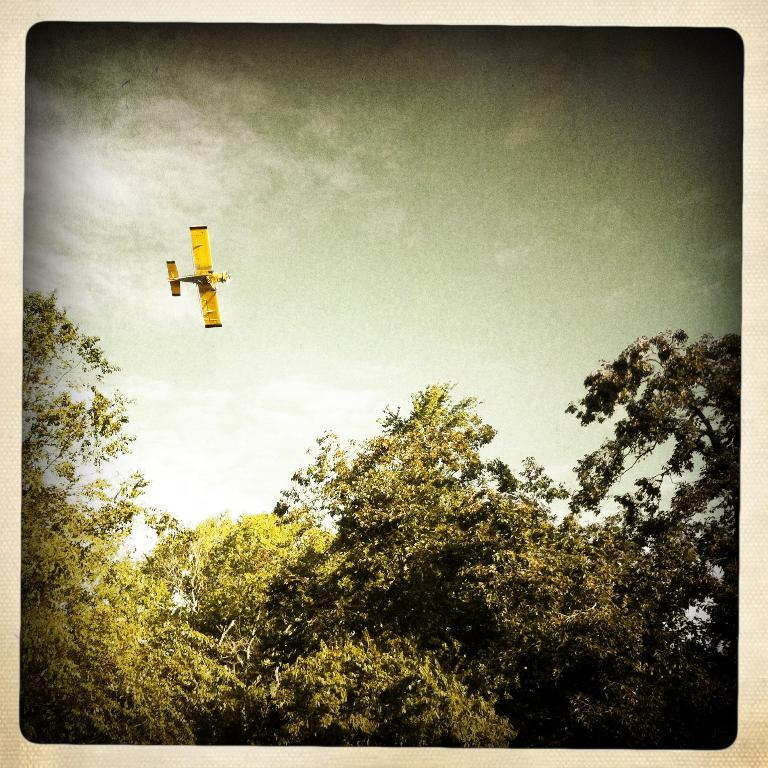What type of vegetation can be seen in the image? There are trees in the image. What is flying in the sky in the image? There is an airplane flying in the sky in the image. How many children are playing on the airplane's wing in the image? There are no children present in the image, nor is anyone playing on the airplane's wing. 